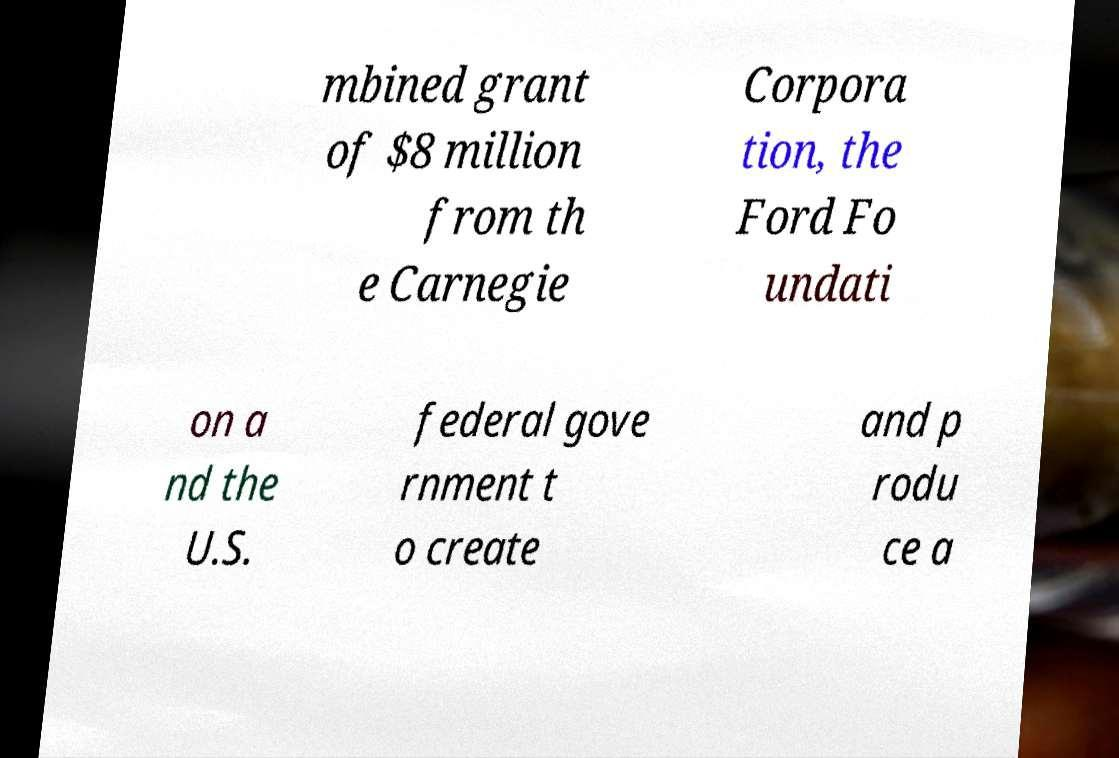Can you accurately transcribe the text from the provided image for me? mbined grant of $8 million from th e Carnegie Corpora tion, the Ford Fo undati on a nd the U.S. federal gove rnment t o create and p rodu ce a 